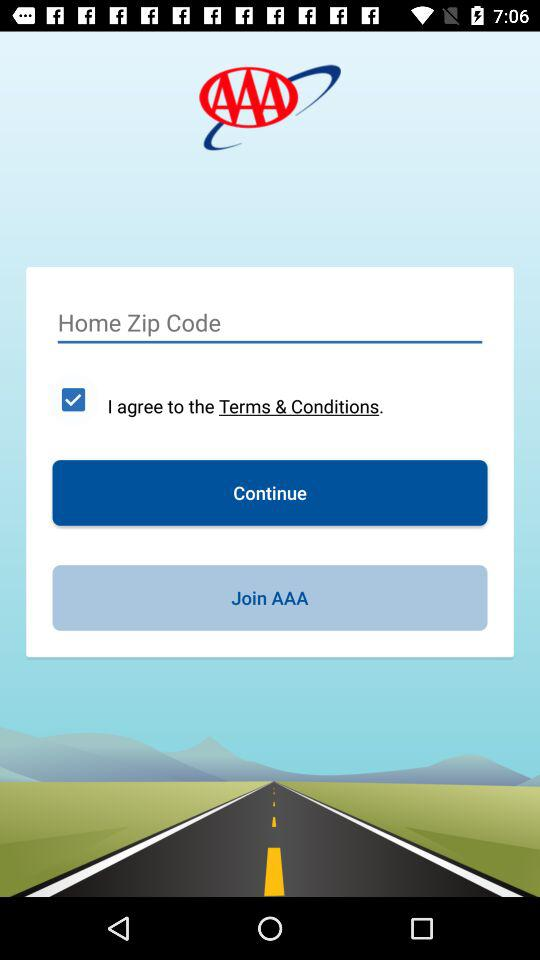What option has been checked? The option that has been checked is "I agree to the Terms & Conditions". 